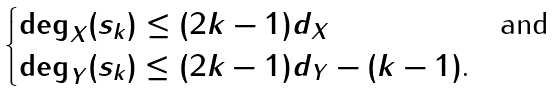<formula> <loc_0><loc_0><loc_500><loc_500>\begin{cases} \deg _ { X } ( s _ { k } ) \leq ( 2 k - 1 ) d _ { X } & \text {and} \\ \deg _ { Y } ( s _ { k } ) \leq ( 2 k - 1 ) d _ { Y } - ( k - 1 ) \text  . \end{cases}</formula> 